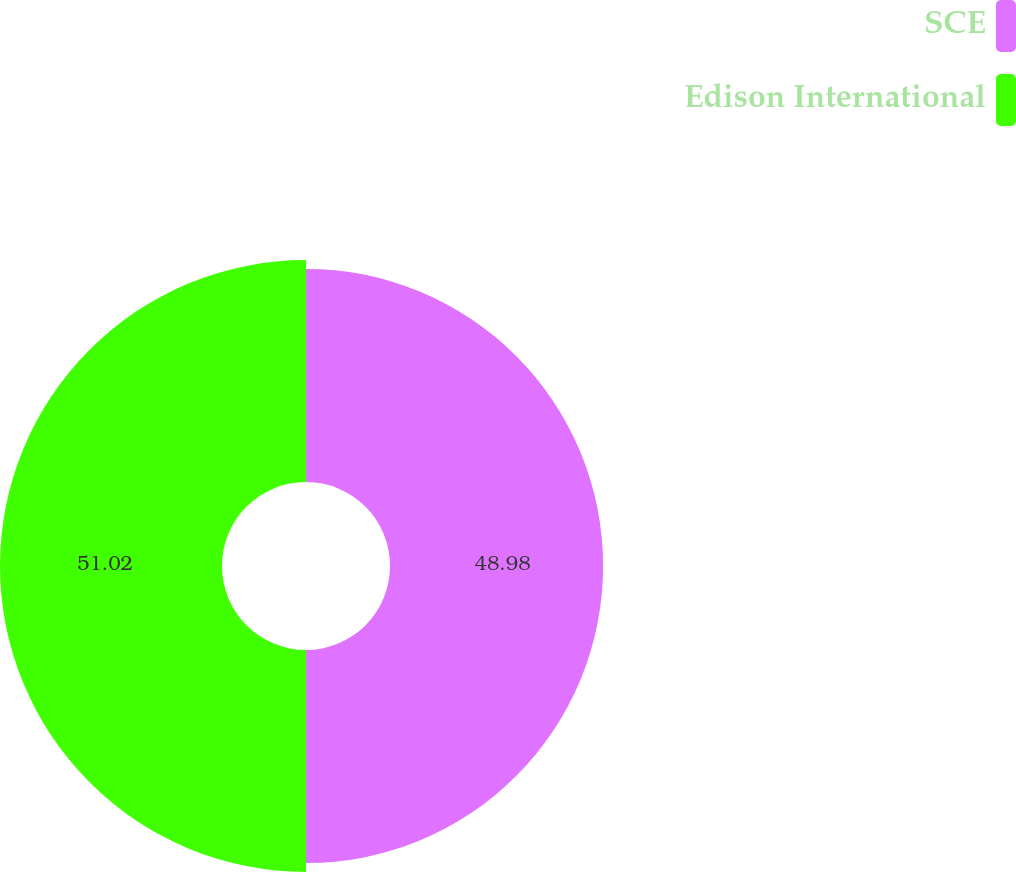Convert chart to OTSL. <chart><loc_0><loc_0><loc_500><loc_500><pie_chart><fcel>SCE<fcel>Edison International<nl><fcel>48.98%<fcel>51.02%<nl></chart> 